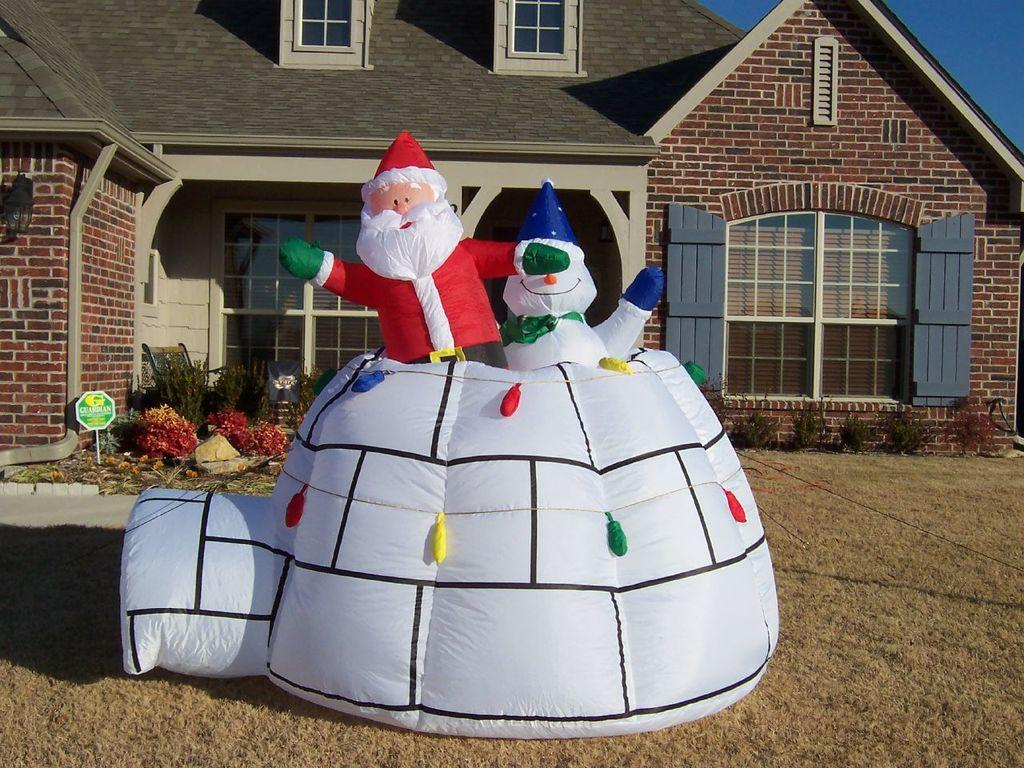What type of toys are visible in the image? There are balloon toys in the image. What type of terrain is visible in the image? There is grass in the image. What structures can be seen in the background of the image? There is a board with a pole, plants, a house, a light, windows, and the sky visible in the background. What type of bells can be heard ringing in the image? There are no bells present in the image, and therefore no sounds can be heard. 